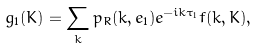<formula> <loc_0><loc_0><loc_500><loc_500>g _ { 1 } ( K ) = \sum _ { k } p _ { R } ( k , { e } _ { 1 } ) e ^ { - i k \tau _ { 1 } } f ( k , K ) ,</formula> 